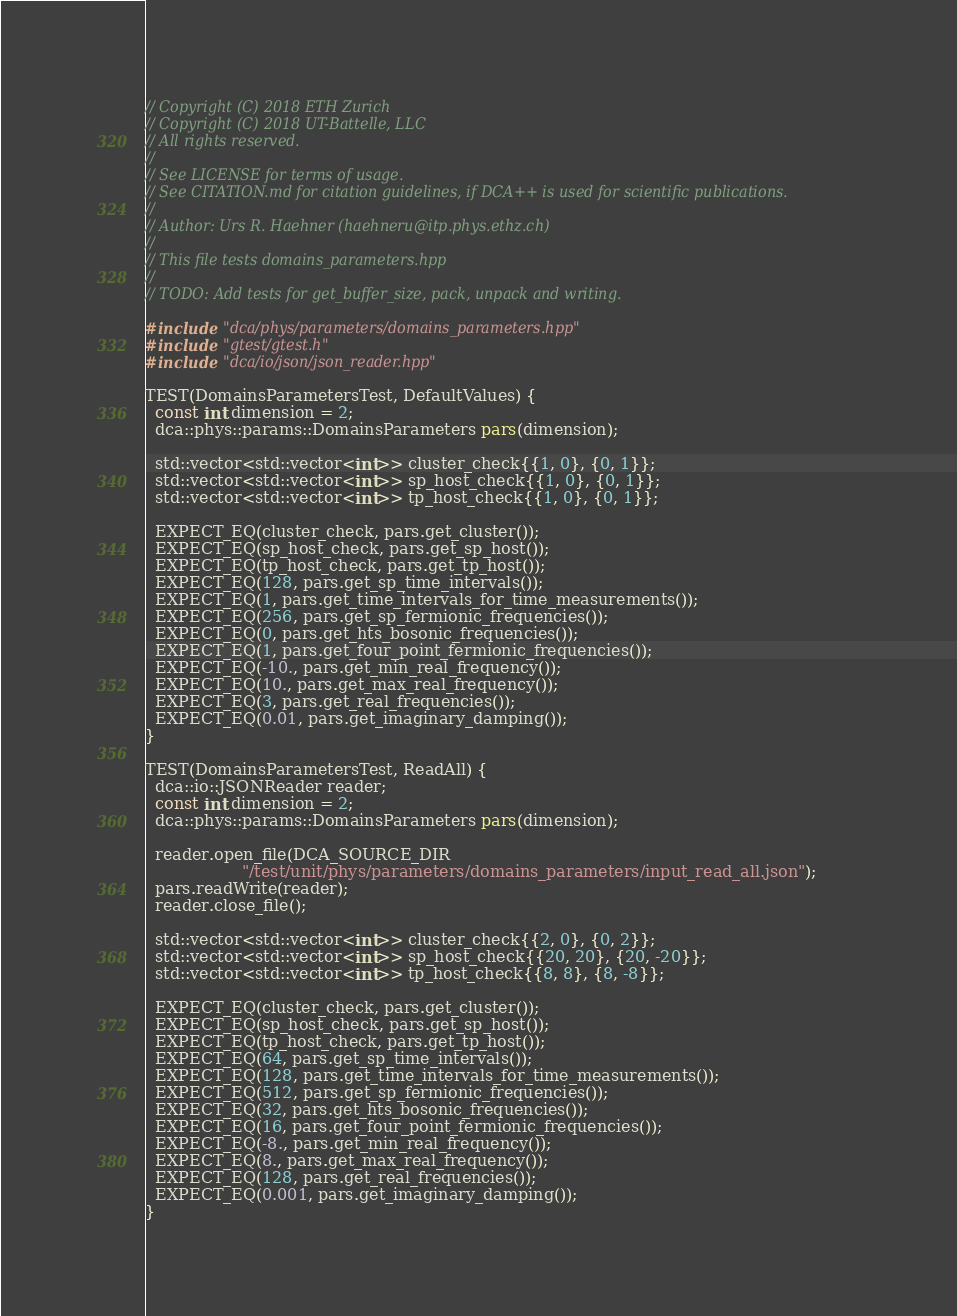<code> <loc_0><loc_0><loc_500><loc_500><_C++_>// Copyright (C) 2018 ETH Zurich
// Copyright (C) 2018 UT-Battelle, LLC
// All rights reserved.
//
// See LICENSE for terms of usage.
// See CITATION.md for citation guidelines, if DCA++ is used for scientific publications.
//
// Author: Urs R. Haehner (haehneru@itp.phys.ethz.ch)
//
// This file tests domains_parameters.hpp
//
// TODO: Add tests for get_buffer_size, pack, unpack and writing.

#include "dca/phys/parameters/domains_parameters.hpp"
#include "gtest/gtest.h"
#include "dca/io/json/json_reader.hpp"

TEST(DomainsParametersTest, DefaultValues) {
  const int dimension = 2;
  dca::phys::params::DomainsParameters pars(dimension);

  std::vector<std::vector<int>> cluster_check{{1, 0}, {0, 1}};
  std::vector<std::vector<int>> sp_host_check{{1, 0}, {0, 1}};
  std::vector<std::vector<int>> tp_host_check{{1, 0}, {0, 1}};

  EXPECT_EQ(cluster_check, pars.get_cluster());
  EXPECT_EQ(sp_host_check, pars.get_sp_host());
  EXPECT_EQ(tp_host_check, pars.get_tp_host());
  EXPECT_EQ(128, pars.get_sp_time_intervals());
  EXPECT_EQ(1, pars.get_time_intervals_for_time_measurements());
  EXPECT_EQ(256, pars.get_sp_fermionic_frequencies());
  EXPECT_EQ(0, pars.get_hts_bosonic_frequencies());
  EXPECT_EQ(1, pars.get_four_point_fermionic_frequencies());
  EXPECT_EQ(-10., pars.get_min_real_frequency());
  EXPECT_EQ(10., pars.get_max_real_frequency());
  EXPECT_EQ(3, pars.get_real_frequencies());
  EXPECT_EQ(0.01, pars.get_imaginary_damping());
}

TEST(DomainsParametersTest, ReadAll) {
  dca::io::JSONReader reader;
  const int dimension = 2;
  dca::phys::params::DomainsParameters pars(dimension);

  reader.open_file(DCA_SOURCE_DIR
                   "/test/unit/phys/parameters/domains_parameters/input_read_all.json");
  pars.readWrite(reader);
  reader.close_file();

  std::vector<std::vector<int>> cluster_check{{2, 0}, {0, 2}};
  std::vector<std::vector<int>> sp_host_check{{20, 20}, {20, -20}};
  std::vector<std::vector<int>> tp_host_check{{8, 8}, {8, -8}};

  EXPECT_EQ(cluster_check, pars.get_cluster());
  EXPECT_EQ(sp_host_check, pars.get_sp_host());
  EXPECT_EQ(tp_host_check, pars.get_tp_host());
  EXPECT_EQ(64, pars.get_sp_time_intervals());
  EXPECT_EQ(128, pars.get_time_intervals_for_time_measurements());
  EXPECT_EQ(512, pars.get_sp_fermionic_frequencies());
  EXPECT_EQ(32, pars.get_hts_bosonic_frequencies());
  EXPECT_EQ(16, pars.get_four_point_fermionic_frequencies());
  EXPECT_EQ(-8., pars.get_min_real_frequency());
  EXPECT_EQ(8., pars.get_max_real_frequency());
  EXPECT_EQ(128, pars.get_real_frequencies());
  EXPECT_EQ(0.001, pars.get_imaginary_damping());
}
</code> 